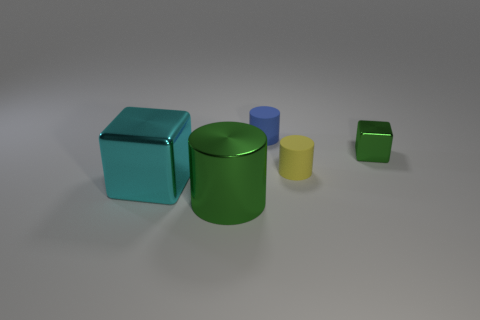How many blue cylinders are there? Upon examining the image, there is actually one small blue cylinder situated to the right of the large green cylinder, and behind the yellow one. 